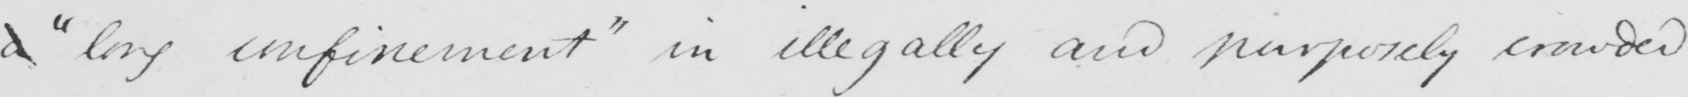Can you read and transcribe this handwriting? a  " long confinement "  in illegally and purposely crowded 